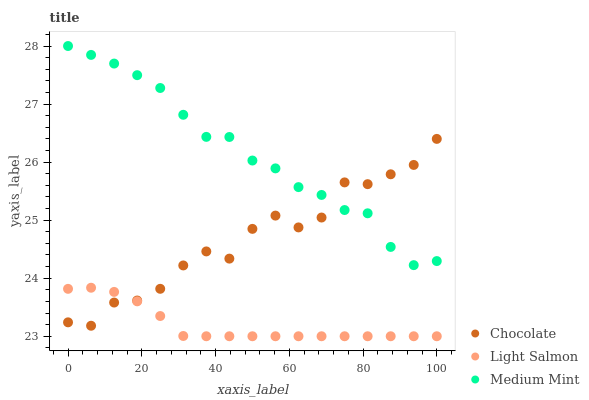Does Light Salmon have the minimum area under the curve?
Answer yes or no. Yes. Does Medium Mint have the maximum area under the curve?
Answer yes or no. Yes. Does Chocolate have the minimum area under the curve?
Answer yes or no. No. Does Chocolate have the maximum area under the curve?
Answer yes or no. No. Is Light Salmon the smoothest?
Answer yes or no. Yes. Is Chocolate the roughest?
Answer yes or no. Yes. Is Chocolate the smoothest?
Answer yes or no. No. Is Light Salmon the roughest?
Answer yes or no. No. Does Light Salmon have the lowest value?
Answer yes or no. Yes. Does Chocolate have the lowest value?
Answer yes or no. No. Does Medium Mint have the highest value?
Answer yes or no. Yes. Does Chocolate have the highest value?
Answer yes or no. No. Is Light Salmon less than Medium Mint?
Answer yes or no. Yes. Is Medium Mint greater than Light Salmon?
Answer yes or no. Yes. Does Chocolate intersect Light Salmon?
Answer yes or no. Yes. Is Chocolate less than Light Salmon?
Answer yes or no. No. Is Chocolate greater than Light Salmon?
Answer yes or no. No. Does Light Salmon intersect Medium Mint?
Answer yes or no. No. 